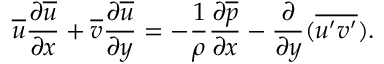Convert formula to latex. <formula><loc_0><loc_0><loc_500><loc_500>{ \overline { u } } { \frac { \partial { \overline { u } } } { \partial x } } + { \overline { v } } { \frac { \partial { \overline { u } } } { \partial y } } = - { \frac { 1 } { \rho } } { \frac { \partial { \overline { p } } } { \partial x } } - { \frac { \partial } { \partial y } } ( { \overline { { u ^ { \prime } v ^ { \prime } } } } ) .</formula> 